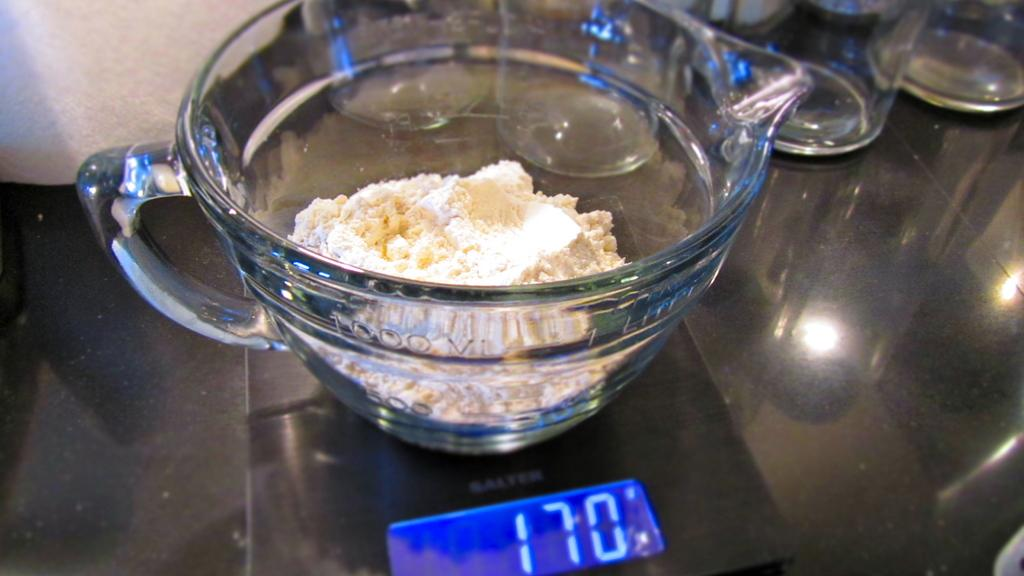<image>
Relay a brief, clear account of the picture shown. Beaker on a weight which shows 170 on the screen. 